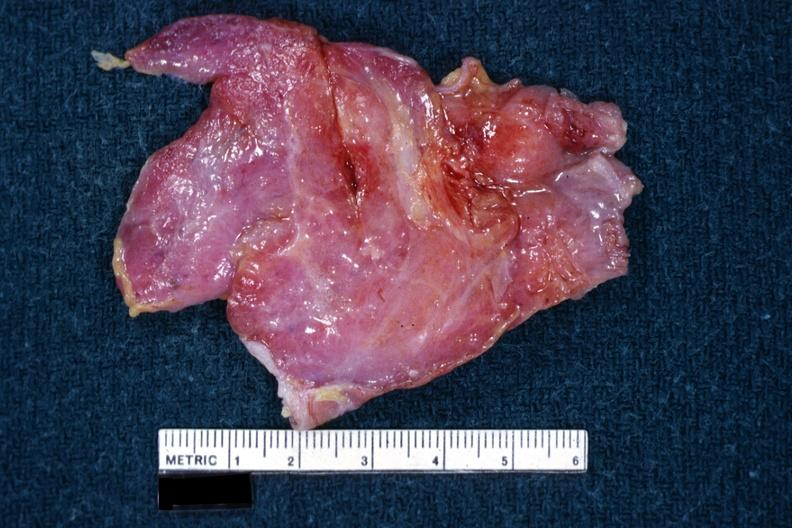where is this part in?
Answer the question using a single word or phrase. Thymus 